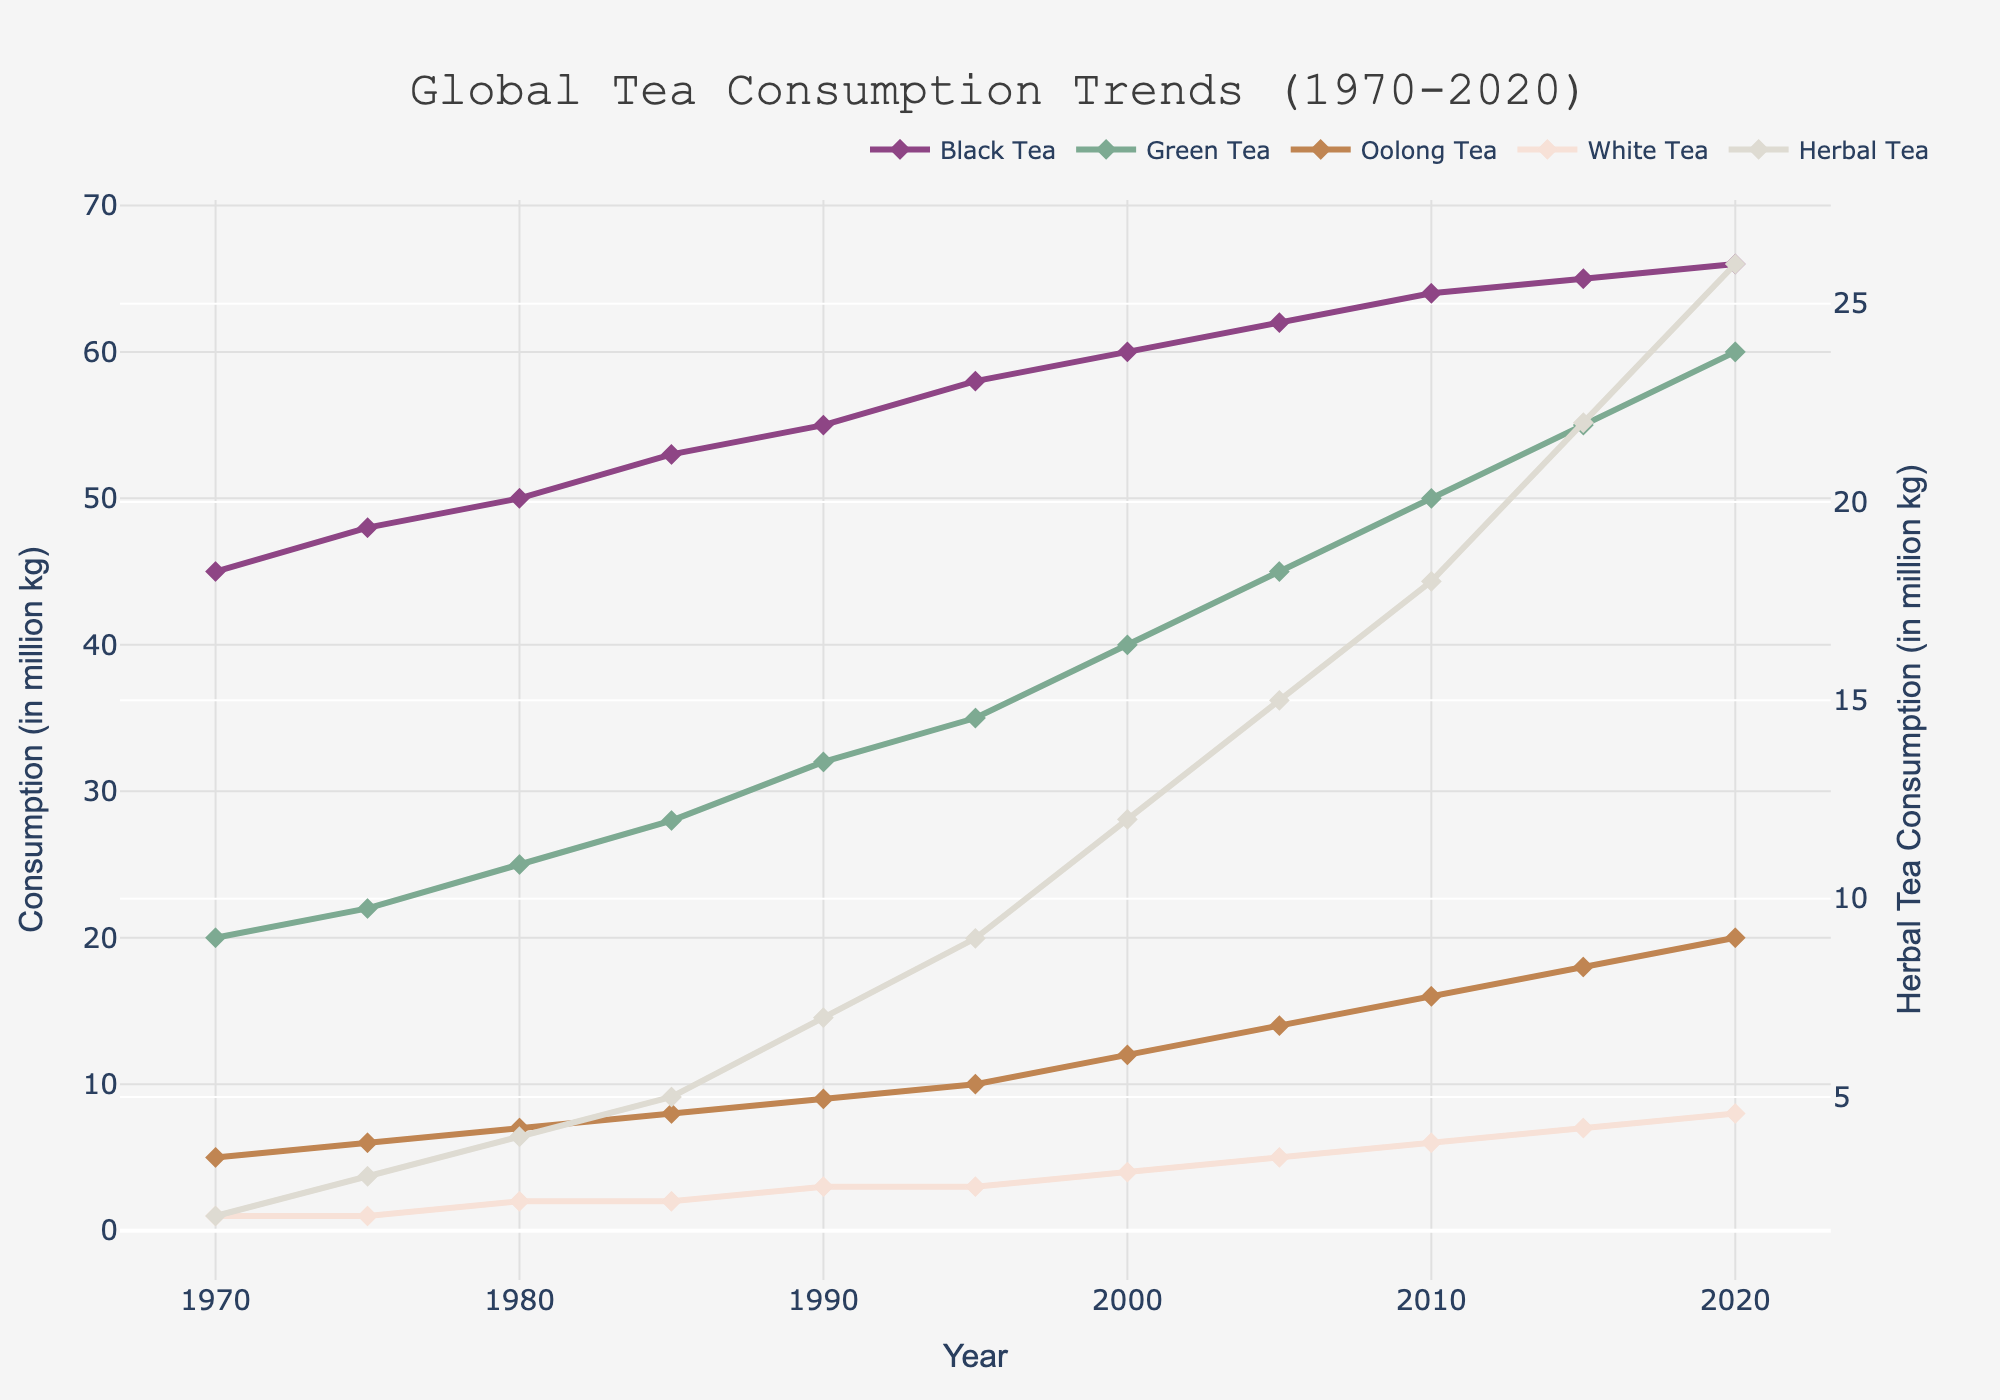What is the trend in black tea consumption from 1970 to 2020? From 1970 to 2020, the black tea consumption shows a steady increase. The line starts at 45 million kg in 1970 and ends at 66 million kg in 2020. This consistent upward trend indicates growing popularity over the years.
Answer: An increase Which type of tea had the highest consumption in 2020? By looking at the end of the lines on the chart in 2020, black tea has the highest consumption at 66 million kg.
Answer: Black Tea In which year did green tea consumption surpass 50 million kg? By following the green tea line on the chart, it surpasses 50 million kg at the mark labeled 2010.
Answer: 2010 How many more million kg of herbal tea was consumed in 2020 compared to 1970? By examining the chart, herbal tea consumption was 2 million kg in 1970 and increased to 26 million kg in 2020. The difference is 26 - 2 = 24 million kg.
Answer: 24 million kg Calculate the average consumption of oolong tea from 1970 to 2020. Summing the oolong tea values (5, 6, 7, 8, 9, 10, 12, 14, 16, 18, 20) and dividing by the number of years (11) gives (5 + 6 + 7 + 8 + 9 + 10 + 12 + 14 + 16 + 18 + 20) / 11 = 125 / 11 ≈ 11.36
Answer: 11.36 million kg Which tea type shows the steepest increase in consumption between 2000 and 2020? By examining the slopes between 2000 and 2020, herbal tea's line shows the steepest increase - from 12 to 26 million kg - a 14 million kg increase over 20 years.
Answer: Herbal Tea What year did white tea consumption double from its 1970 value of 1 million kg? By observing the white tea line, it doubled its 1970 value reaching 2 million kg at the mark labeled 1980.
Answer: 1980 Compare the consumption trends of green tea and black tea. Which has grown faster? Visually comparing both lines from the start in 1970, green tea grows from 20 to 60 million kg (an increase of 40 million kg) while black tea grows from 45 to 66 million kg (an increase of 21 million kg). So, green tea has grown faster.
Answer: Green Tea What is the difference between the consumption of green tea and oolong tea in 1985? From the chart, in 1985, green tea consumption was 28 million kg while oolong tea consumption was 8. The difference is 28 - 8 = 20 million kg.
Answer: 20 million kg Determine the ratio of herbal tea consumption to white tea consumption in 2010. In 2010, herbal tea consumption is 18 million kg and white tea consumption is 6 million kg. The ratio 18:6 can be simplified to 3:1.
Answer: 3:1 